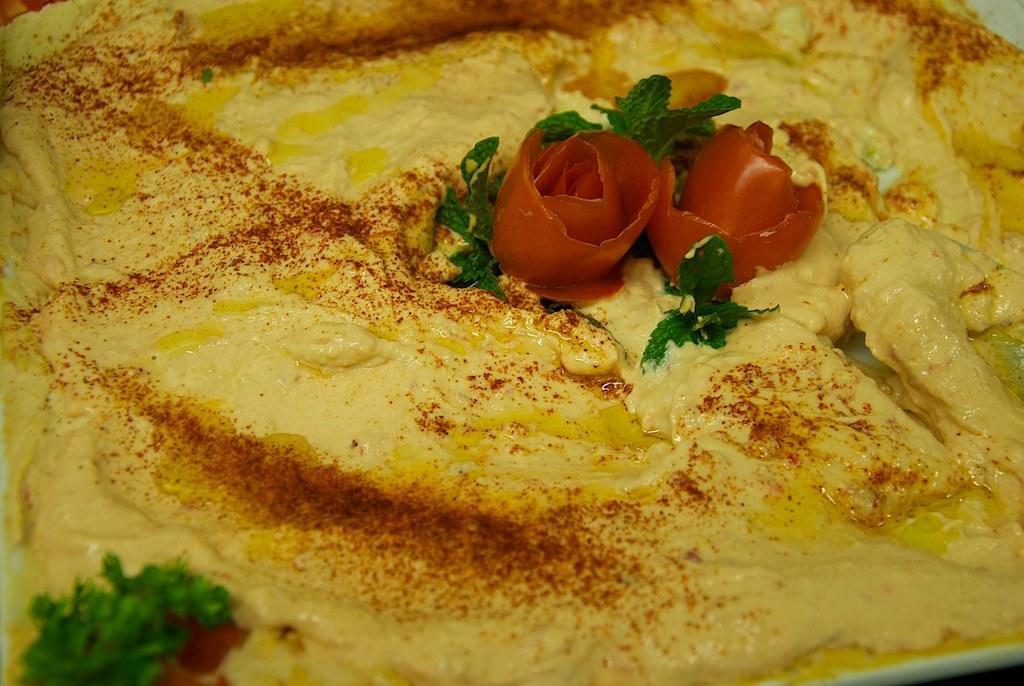Please provide a concise description of this image. In this image we can see an omelette garnished with chili powder, tomato slices and some mint leaves. 